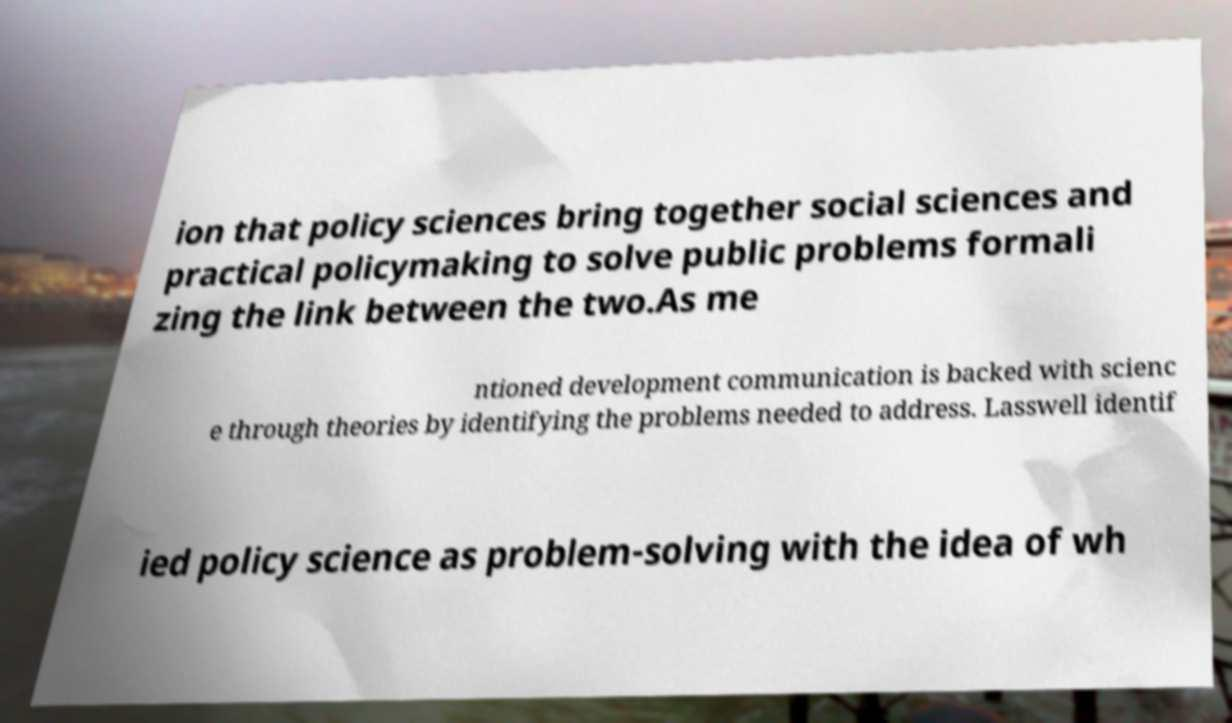What messages or text are displayed in this image? I need them in a readable, typed format. ion that policy sciences bring together social sciences and practical policymaking to solve public problems formali zing the link between the two.As me ntioned development communication is backed with scienc e through theories by identifying the problems needed to address. Lasswell identif ied policy science as problem-solving with the idea of wh 